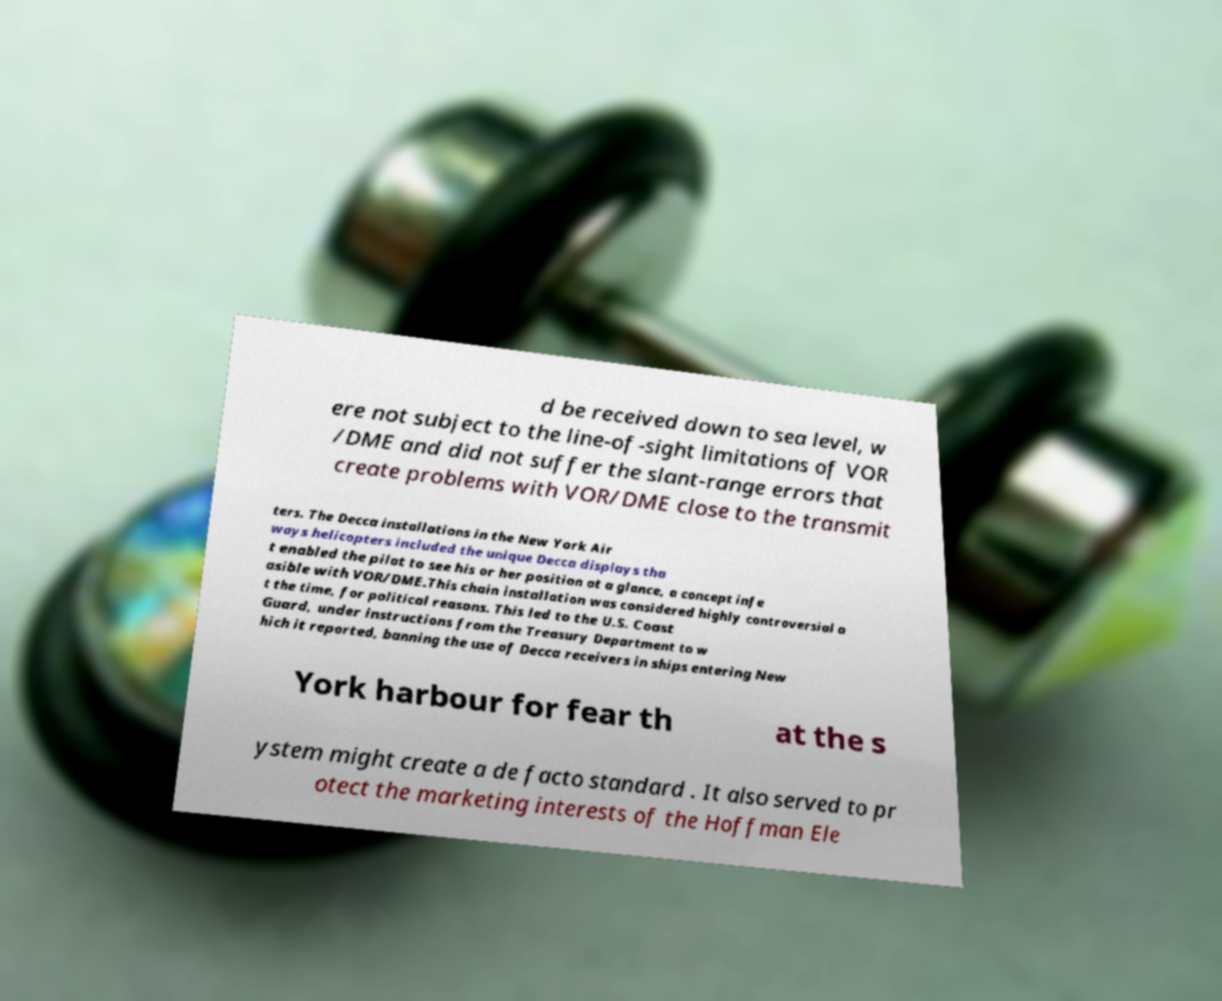For documentation purposes, I need the text within this image transcribed. Could you provide that? d be received down to sea level, w ere not subject to the line-of-sight limitations of VOR /DME and did not suffer the slant-range errors that create problems with VOR/DME close to the transmit ters. The Decca installations in the New York Air ways helicopters included the unique Decca displays tha t enabled the pilot to see his or her position at a glance, a concept infe asible with VOR/DME.This chain installation was considered highly controversial a t the time, for political reasons. This led to the U.S. Coast Guard, under instructions from the Treasury Department to w hich it reported, banning the use of Decca receivers in ships entering New York harbour for fear th at the s ystem might create a de facto standard . It also served to pr otect the marketing interests of the Hoffman Ele 